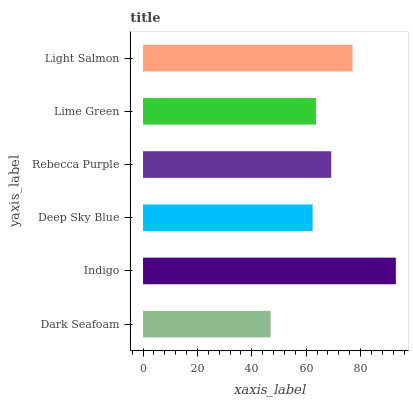Is Dark Seafoam the minimum?
Answer yes or no. Yes. Is Indigo the maximum?
Answer yes or no. Yes. Is Deep Sky Blue the minimum?
Answer yes or no. No. Is Deep Sky Blue the maximum?
Answer yes or no. No. Is Indigo greater than Deep Sky Blue?
Answer yes or no. Yes. Is Deep Sky Blue less than Indigo?
Answer yes or no. Yes. Is Deep Sky Blue greater than Indigo?
Answer yes or no. No. Is Indigo less than Deep Sky Blue?
Answer yes or no. No. Is Rebecca Purple the high median?
Answer yes or no. Yes. Is Lime Green the low median?
Answer yes or no. Yes. Is Light Salmon the high median?
Answer yes or no. No. Is Rebecca Purple the low median?
Answer yes or no. No. 